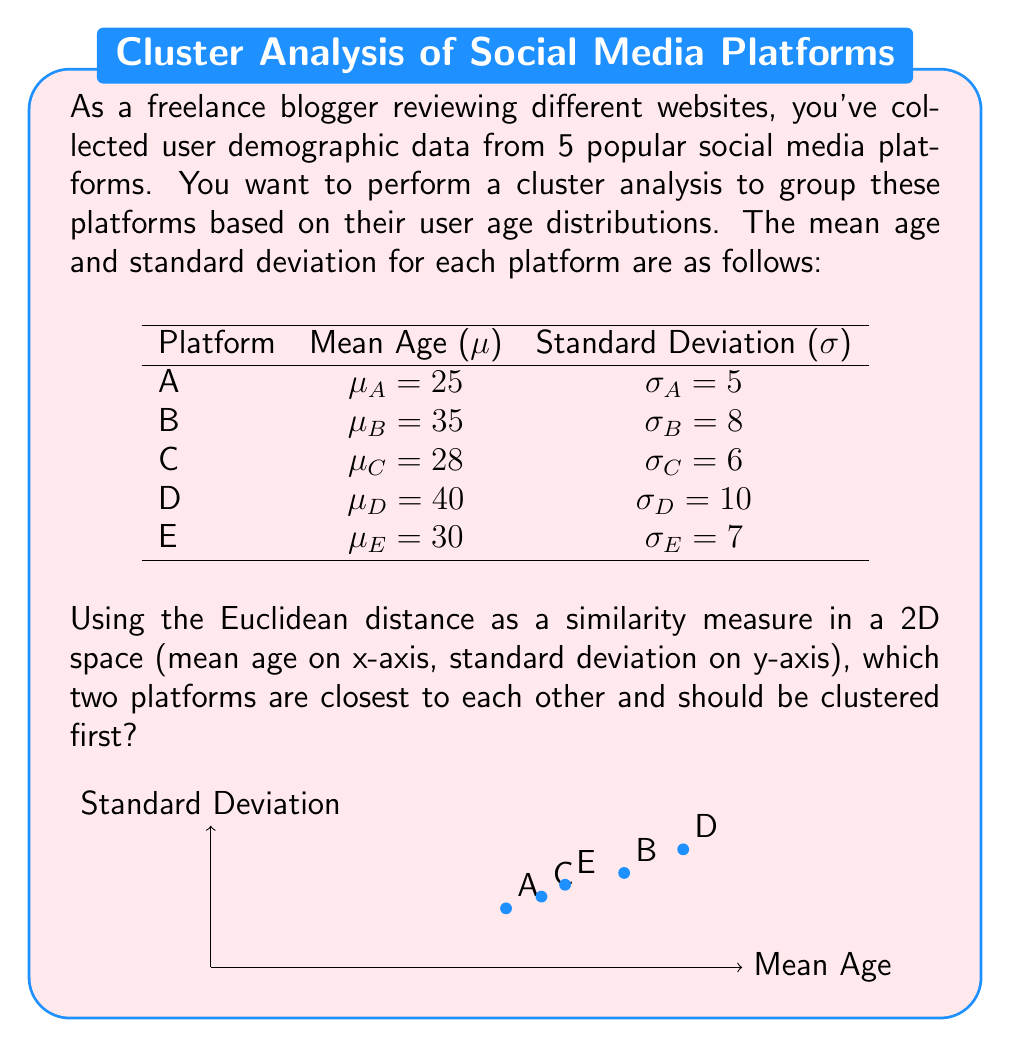Teach me how to tackle this problem. To determine which two platforms are closest and should be clustered first, we need to calculate the Euclidean distance between each pair of platforms in the 2D space defined by mean age and standard deviation.

The Euclidean distance between two points $(x_1, y_1)$ and $(x_2, y_2)$ is given by:

$$d = \sqrt{(x_2 - x_1)^2 + (y_2 - y_1)^2}$$

Let's calculate the distances between each pair:

1. A and B: $d_{AB} = \sqrt{(35 - 25)^2 + (8 - 5)^2} = \sqrt{100 + 9} = \sqrt{109} \approx 10.44$
2. A and C: $d_{AC} = \sqrt{(28 - 25)^2 + (6 - 5)^2} = \sqrt{9 + 1} = \sqrt{10} \approx 3.16$
3. A and D: $d_{AD} = \sqrt{(40 - 25)^2 + (10 - 5)^2} = \sqrt{225 + 25} = \sqrt{250} \approx 15.81$
4. A and E: $d_{AE} = \sqrt{(30 - 25)^2 + (7 - 5)^2} = \sqrt{25 + 4} = \sqrt{29} \approx 5.39$
5. B and C: $d_{BC} = \sqrt{(35 - 28)^2 + (8 - 6)^2} = \sqrt{49 + 4} = \sqrt{53} \approx 7.28$
6. B and D: $d_{BD} = \sqrt{(40 - 35)^2 + (10 - 8)^2} = \sqrt{25 + 4} = \sqrt{29} \approx 5.39$
7. B and E: $d_{BE} = \sqrt{(35 - 30)^2 + (8 - 7)^2} = \sqrt{25 + 1} = \sqrt{26} \approx 5.10$
8. C and D: $d_{CD} = \sqrt{(40 - 28)^2 + (10 - 6)^2} = \sqrt{144 + 16} = \sqrt{160} \approx 12.65$
9. C and E: $d_{CE} = \sqrt{(30 - 28)^2 + (7 - 6)^2} = \sqrt{4 + 1} = \sqrt{5} \approx 2.24$
10. D and E: $d_{DE} = \sqrt{(40 - 30)^2 + (10 - 7)^2} = \sqrt{100 + 9} = \sqrt{109} \approx 10.44$

The smallest distance is between platforms C and E, approximately 2.24.
Answer: Platforms C and E 